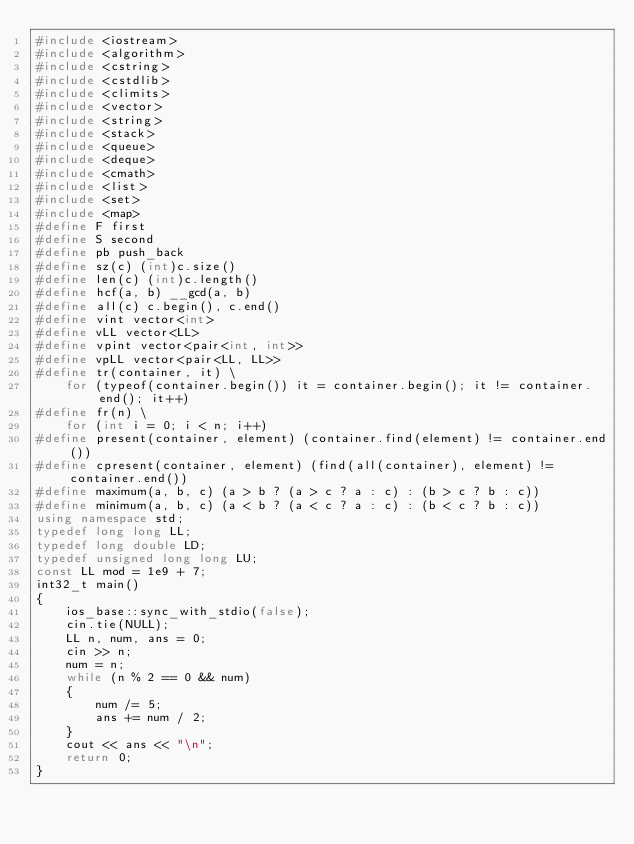<code> <loc_0><loc_0><loc_500><loc_500><_C++_>#include <iostream>
#include <algorithm>
#include <cstring>
#include <cstdlib>
#include <climits>
#include <vector>
#include <string>
#include <stack>
#include <queue>
#include <deque>
#include <cmath>
#include <list>
#include <set>
#include <map>
#define F first
#define S second
#define pb push_back
#define sz(c) (int)c.size()
#define len(c) (int)c.length()
#define hcf(a, b) __gcd(a, b)
#define all(c) c.begin(), c.end()
#define vint vector<int>
#define vLL vector<LL>
#define vpint vector<pair<int, int>>
#define vpLL vector<pair<LL, LL>>
#define tr(container, it) \
    for (typeof(container.begin()) it = container.begin(); it != container.end(); it++)
#define fr(n) \
    for (int i = 0; i < n; i++)
#define present(container, element) (container.find(element) != container.end())
#define cpresent(container, element) (find(all(container), element) != container.end())
#define maximum(a, b, c) (a > b ? (a > c ? a : c) : (b > c ? b : c))
#define minimum(a, b, c) (a < b ? (a < c ? a : c) : (b < c ? b : c))
using namespace std;
typedef long long LL;
typedef long double LD;
typedef unsigned long long LU;
const LL mod = 1e9 + 7;
int32_t main()
{
    ios_base::sync_with_stdio(false);
    cin.tie(NULL);
    LL n, num, ans = 0;
    cin >> n;
    num = n;
    while (n % 2 == 0 && num)
    {
        num /= 5;
        ans += num / 2;
    }
    cout << ans << "\n";
    return 0;
}</code> 